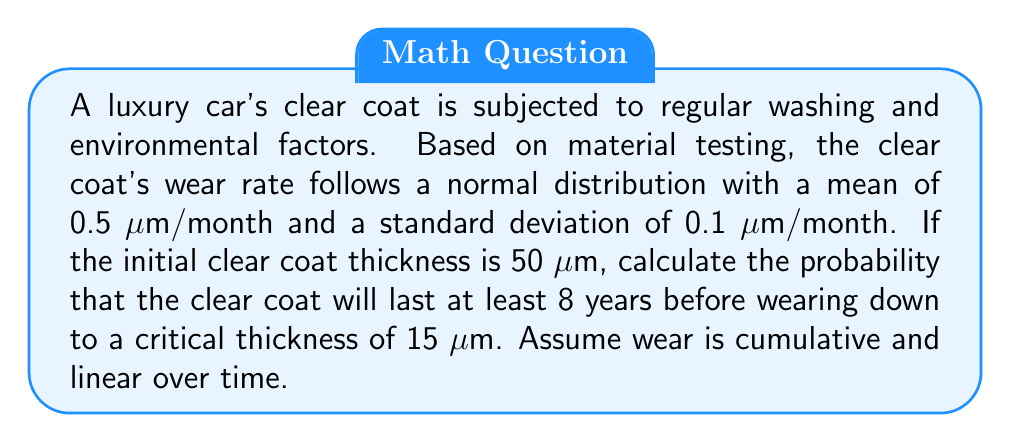Help me with this question. Let's approach this step-by-step:

1) First, we need to calculate the total wear over 8 years:
   $50 \text{ μm} - 15 \text{ μm} = 35 \text{ μm}$

2) Now, let's calculate the average monthly wear over 8 years:
   $35 \text{ μm} \div (8 \times 12) = 0.3645833 \text{ μm/month}$

3) We know that the wear rate follows a normal distribution with:
   $\mu = 0.5 \text{ μm/month}$
   $\sigma = 0.1 \text{ μm/month}$

4) To find the probability, we need to calculate the z-score:
   $$z = \frac{x - \mu}{\sigma} = \frac{0.3645833 - 0.5}{0.1} = -1.3541667$$

5) Now, we need to find the probability that the wear rate is less than or equal to 0.3645833 μm/month. This is equivalent to finding the area to the left of z = -1.3541667 under the standard normal curve.

6) Using a standard normal table or calculator, we can find:
   $P(Z \leq -1.3541667) \approx 0.0878$

7) Therefore, the probability that the clear coat will last at least 8 years is approximately 0.0878 or 8.78%.
Answer: 0.0878 (or 8.78%) 